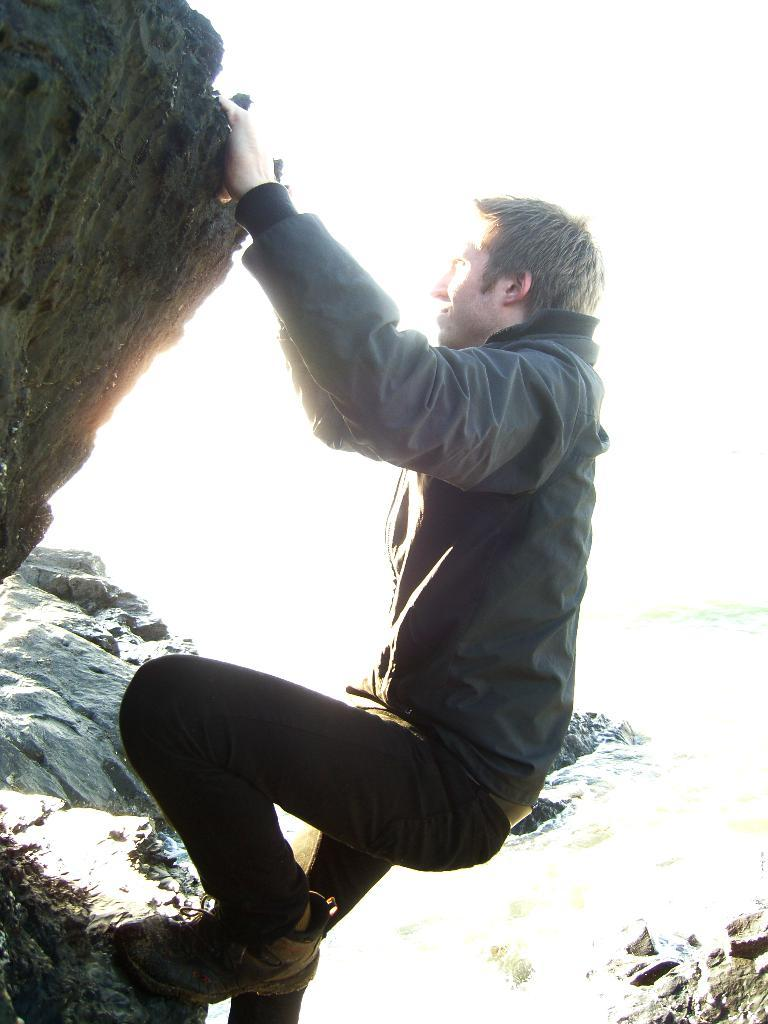Who or what is present in the image? There is a person in the image. What type of natural elements can be seen in the image? There are rocks visible in the image. What is the color of the background in the image? The background of the image appears to be white. What type of brush is being used by the person in the image? There is no brush visible in the image, and the person's actions are not described. 